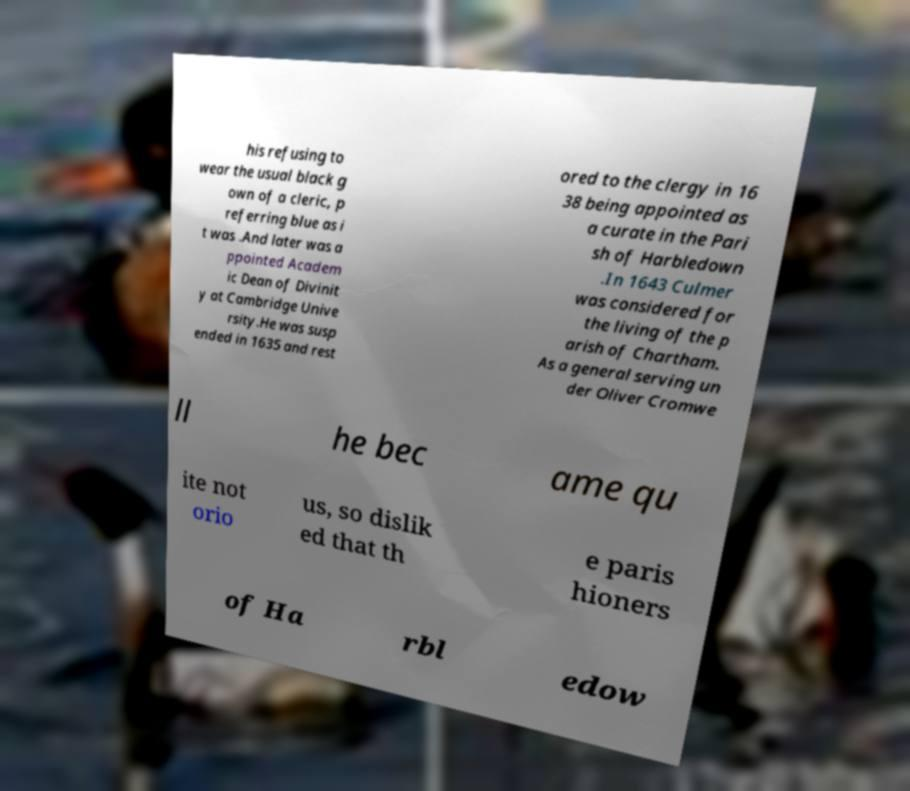Could you assist in decoding the text presented in this image and type it out clearly? his refusing to wear the usual black g own of a cleric, p referring blue as i t was .And later was a ppointed Academ ic Dean of Divinit y at Cambridge Unive rsity.He was susp ended in 1635 and rest ored to the clergy in 16 38 being appointed as a curate in the Pari sh of Harbledown .In 1643 Culmer was considered for the living of the p arish of Chartham. As a general serving un der Oliver Cromwe ll he bec ame qu ite not orio us, so dislik ed that th e paris hioners of Ha rbl edow 